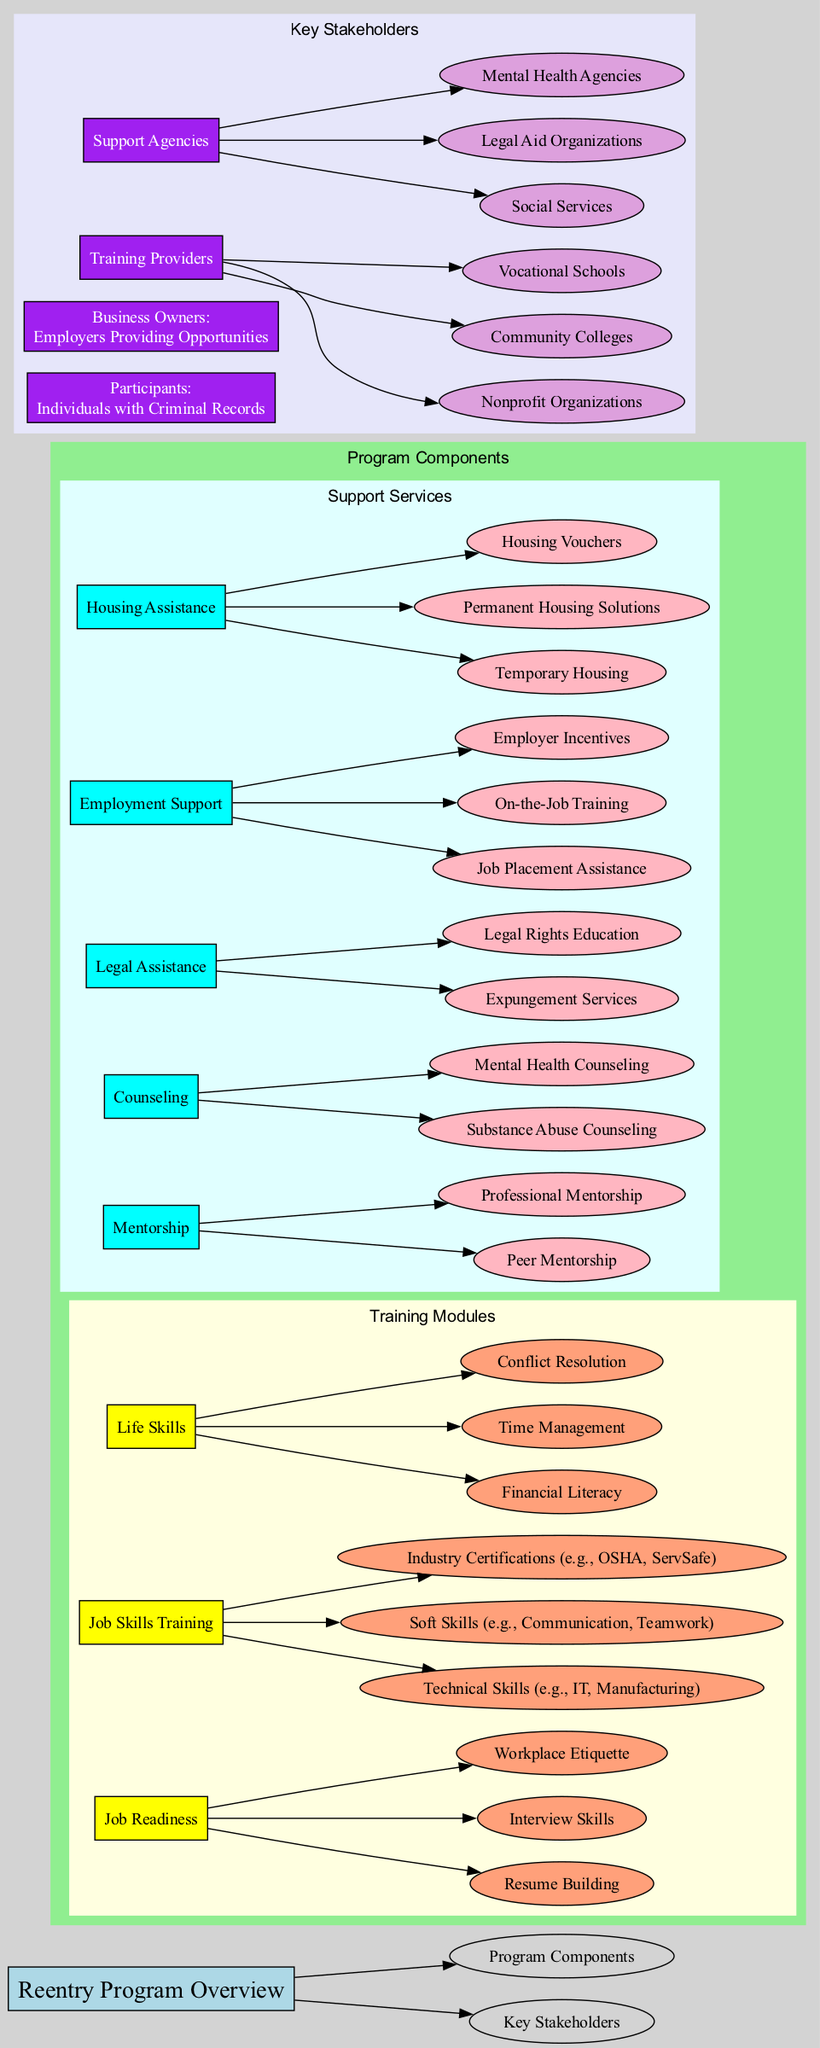What are the main components of the Reentry Program? The Reentry Program consists of two main components, which are "Training Modules" and "Support Services." These categories hold various subcategories that include different training and support options.
Answer: Training Modules, Support Services How many training modules are listed in the diagram? The diagram lists three main training modules: Job Readiness, Job Skills Training, and Life Skills. This count includes all modules that provide training for participants.
Answer: 3 What type of mentorship is provided in the Support Services? The Support Services include two types of mentorship: Peer Mentorship and Professional Mentorship, both designed to support individuals during the reentry process.
Answer: Peer Mentorship, Professional Mentorship Which service offers job placement assistance? "Employment Support" under Support Services offers "Job Placement Assistance," helping participants find and secure employment as they reintegrate into society.
Answer: Job Placement Assistance How many life skills topics are included in the Training Modules? The Life Skills training module comprises three topics: Financial Literacy, Time Management, and Conflict Resolution, thus totaling three life skills topics.
Answer: 3 Who are the participants in the Reentry Program? The participants in the Reentry Program are defined as "Individuals with Criminal Records," who are the primary focus receiving training and support.
Answer: Individuals with Criminal Records What type of assistance does Legal Assistance provide? Legal Assistance includes two key services: "Expungement Services" and "Legal Rights Education," both aimed at helping individuals understand and navigate legal issues.
Answer: Expungement Services, Legal Rights Education What stakeholders provide training in the Reentry Program? Stakeholders providing training include "Nonprofit Organizations," "Community Colleges," and "Vocational Schools." These entities are critical for delivering the training modules.
Answer: Nonprofit Organizations, Community Colleges, Vocational Schools How is 'Technical Skills' categorized in the Training Modules? 'Technical Skills' is categorized under the 'Job Skills Training' module, indicating that it focuses on developing specialized, vocational abilities necessary for specific jobs.
Answer: Job Skills Training 